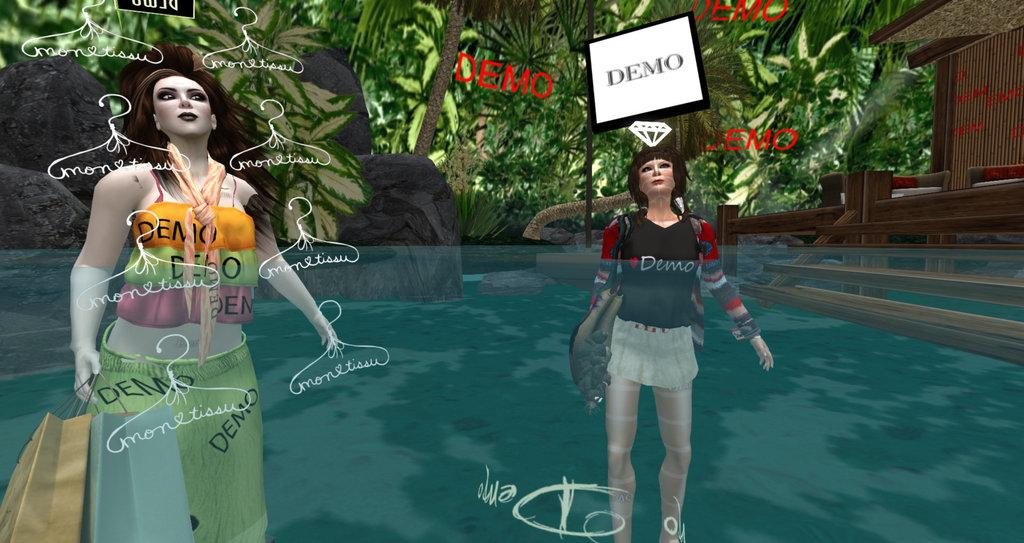What type of image is depicted in the picture? There is an anime image of two ladies in the picture. What are the ladies doing in the image? The ladies are standing inside water. What can be seen in the background of the image? There are trees visible in the background of the image. How many clocks can be seen hanging from the trees in the image? There are no clocks visible in the image; it features an anime image of two ladies standing inside water with trees in the background. What type of ring is the lady on the left wearing on her finger? There is no ring visible on the fingers of the ladies in the image. 